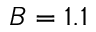<formula> <loc_0><loc_0><loc_500><loc_500>B = 1 . 1</formula> 